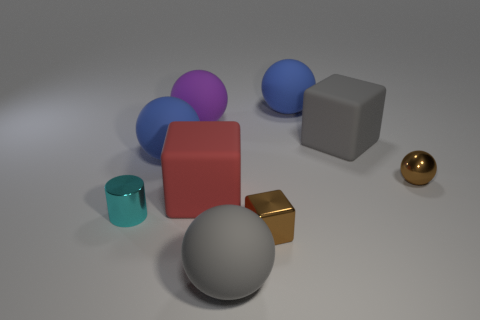There is a small thing that is the same color as the shiny sphere; what is its material?
Keep it short and to the point. Metal. What color is the object that is behind the red block and on the left side of the purple thing?
Offer a very short reply. Blue. There is a sphere that is in front of the tiny brown ball; what is it made of?
Ensure brevity in your answer.  Rubber. How big is the purple ball?
Offer a terse response. Large. What number of red things are large balls or tiny metallic blocks?
Your response must be concise. 0. What size is the blue matte object behind the big blue matte object that is in front of the big gray rubber cube?
Provide a succinct answer. Large. There is a tiny metallic cube; is its color the same as the thing that is behind the large purple ball?
Keep it short and to the point. No. What number of other things are there of the same material as the purple object
Provide a short and direct response. 5. There is a large red thing that is made of the same material as the big gray sphere; what is its shape?
Provide a succinct answer. Cube. Are there any other things of the same color as the small shiny sphere?
Make the answer very short. Yes. 